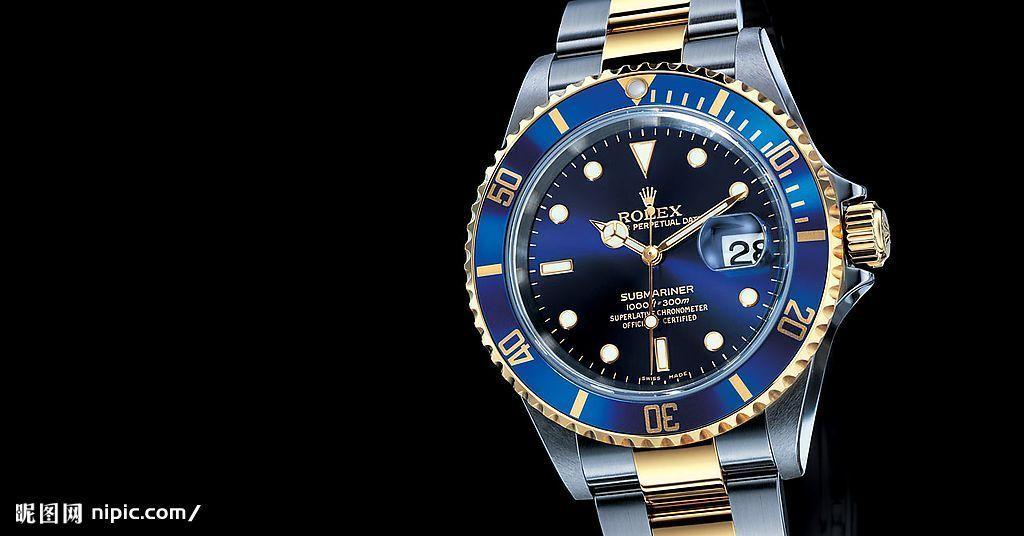What is the date today according to the watch?
Provide a short and direct response. 28. What is the time according to the watch?
Provide a short and direct response. 10:10. 